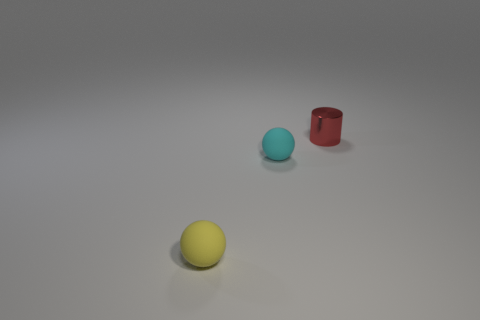There is a sphere that is right of the small matte thing that is to the left of the small cyan sphere; is there a sphere to the left of it?
Provide a short and direct response. Yes. What material is the ball that is to the left of the tiny ball that is behind the rubber thing in front of the cyan rubber thing?
Ensure brevity in your answer.  Rubber. The small rubber thing behind the small yellow ball has what shape?
Make the answer very short. Sphere. What is the size of the ball that is the same material as the small yellow thing?
Ensure brevity in your answer.  Small. What number of small matte objects are the same shape as the small red metal object?
Make the answer very short. 0. How many cyan rubber objects are behind the tiny rubber sphere that is right of the small yellow matte object that is left of the tiny cyan ball?
Keep it short and to the point. 0. What number of things are both behind the tiny yellow matte thing and to the left of the red metallic object?
Offer a very short reply. 1. Is there any other thing that is the same material as the small red cylinder?
Provide a short and direct response. No. Do the cyan sphere and the yellow object have the same material?
Offer a very short reply. Yes. The tiny thing left of the ball that is behind the tiny sphere in front of the cyan thing is what shape?
Your answer should be compact. Sphere. 